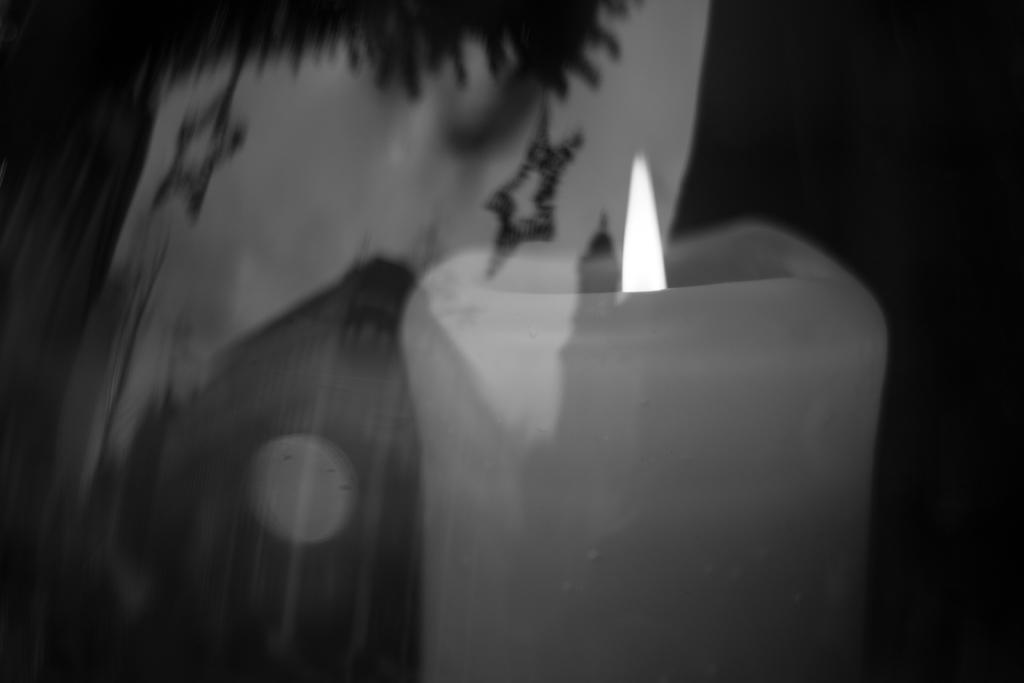What is the main object in the image? There is a candle in the image. Can you describe any other objects in the image? There is an object in the image, but its specific details are not mentioned in the provided facts. What is the color of the background in the image? The background of the image is dark. What type of force is being applied to the candle in the image? There is no indication of any force being applied to the candle in the image. Can you hear any sounds coming from the candle in the image? The image is visual, and there is no mention of any sounds or audio in the provided facts. What type of adjustment is being made to the candle in the image? There is no mention of any adjustment being made to the candle in the provided facts. 